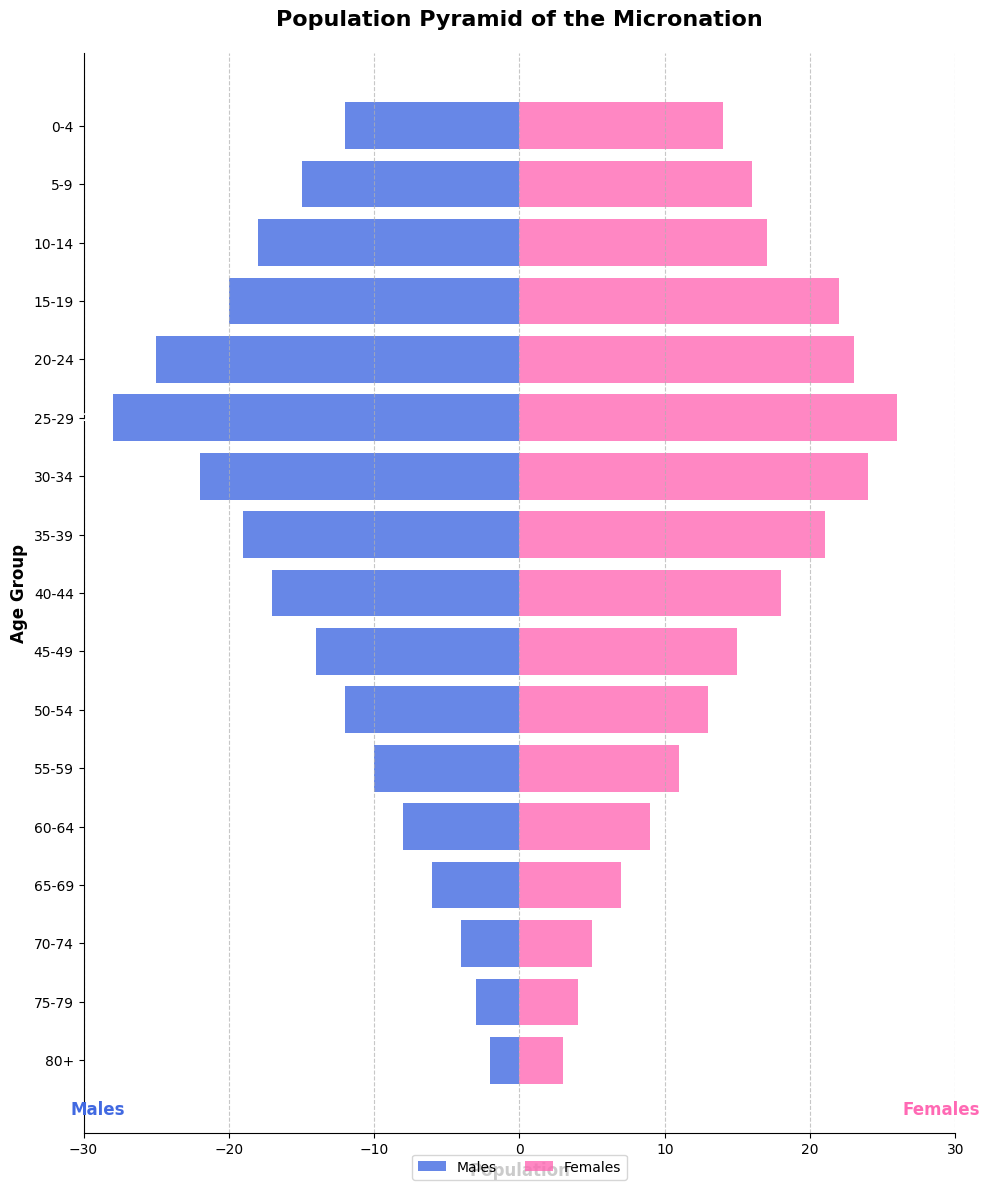What is the title of the figure? The title of the figure is usually placed at the top of the chart. In this case, it is "Population Pyramid of the Micronation".
Answer: Population Pyramid of the Micronation Which age group has the highest number of males? By looking at the length of the bars on the left side (Males), the 25-29 age group has the longest bar, indicating the highest number of males.
Answer: 25-29 What is the population of females in the 20-24 age group? Locate the 20-24 age group on the vertical axis and then refer to the bar on the right side (Females) to find the population count of females, which is 23.
Answer: 23 Compare the populations of males and females in the 80+ age group. Which one is greater? For the 80+ age group, the bar for males is -2 and the bar for females is 3. Since 3 is greater than 2, the female population is greater in this age group.
Answer: Females What is the total population of the 30-34 age group? Sum up the male and female populations in the 30-34 age group: 22 (males) + 24 (females) = 46.
Answer: 46 Which gender has a higher total population in the age groups 0-4 and 5-9 combined? For 0-4 and 5-9: Males = 12 + 15 = 27, Females = 14 + 16 = 30. By comparing 27 and 30, females have a higher total population.
Answer: Females Is the population of males and females in the 40-44 age group equal or different? Compare the male and female population bars for the 40-44 age group. Both populations are 18 (males) and 17 (females), so they are different.
Answer: Different What trend can you observe in the population pyramid as the age increases? The bars for both males and females generally become shorter as the age increases, indicating a decrease in population with increasing age.
Answer: Population decreases with age What is the difference between the male and female population in the 15-19 age group? Subtract the male population from the female population in the 15-19 age group: 22 (females) - 20 (males) = 2.
Answer: 2 In which age group is the gender difference most pronounced? Compare the length of bars for each age group and the absolute difference. The 25-29 age group has 28 males and 26 females, showing the most pronounced difference (28-26 = 2).
Answer: 25-29 